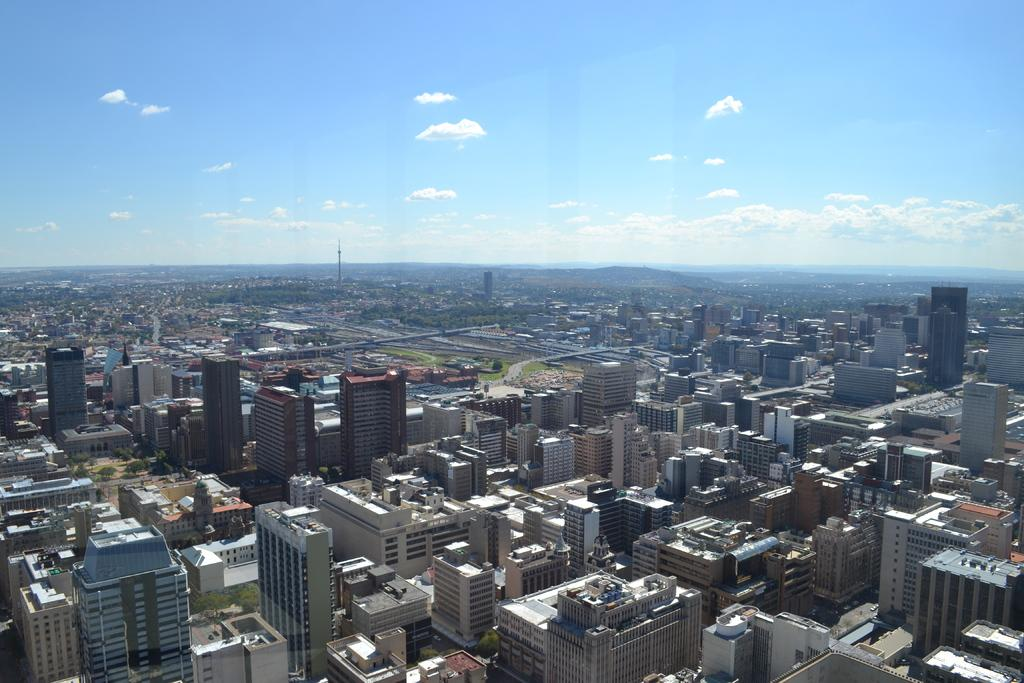What type of structures can be seen in the image? There are buildings in the image. What type of vegetation is present in the image? There are trees and grass in the image. What can be seen in the background of the image? There appears to be a tower in the background of the image. What is visible at the top of the image? The sky is visible at the top of the image. What can be observed in the sky? Clouds are present in the sky. Where is the family's garden located in the image? There is no garden or family present in the image. What type of lock is used to secure the tower in the image? There is no lock or tower mentioned in the image; it only features buildings, trees, grass, and a sky with clouds. 